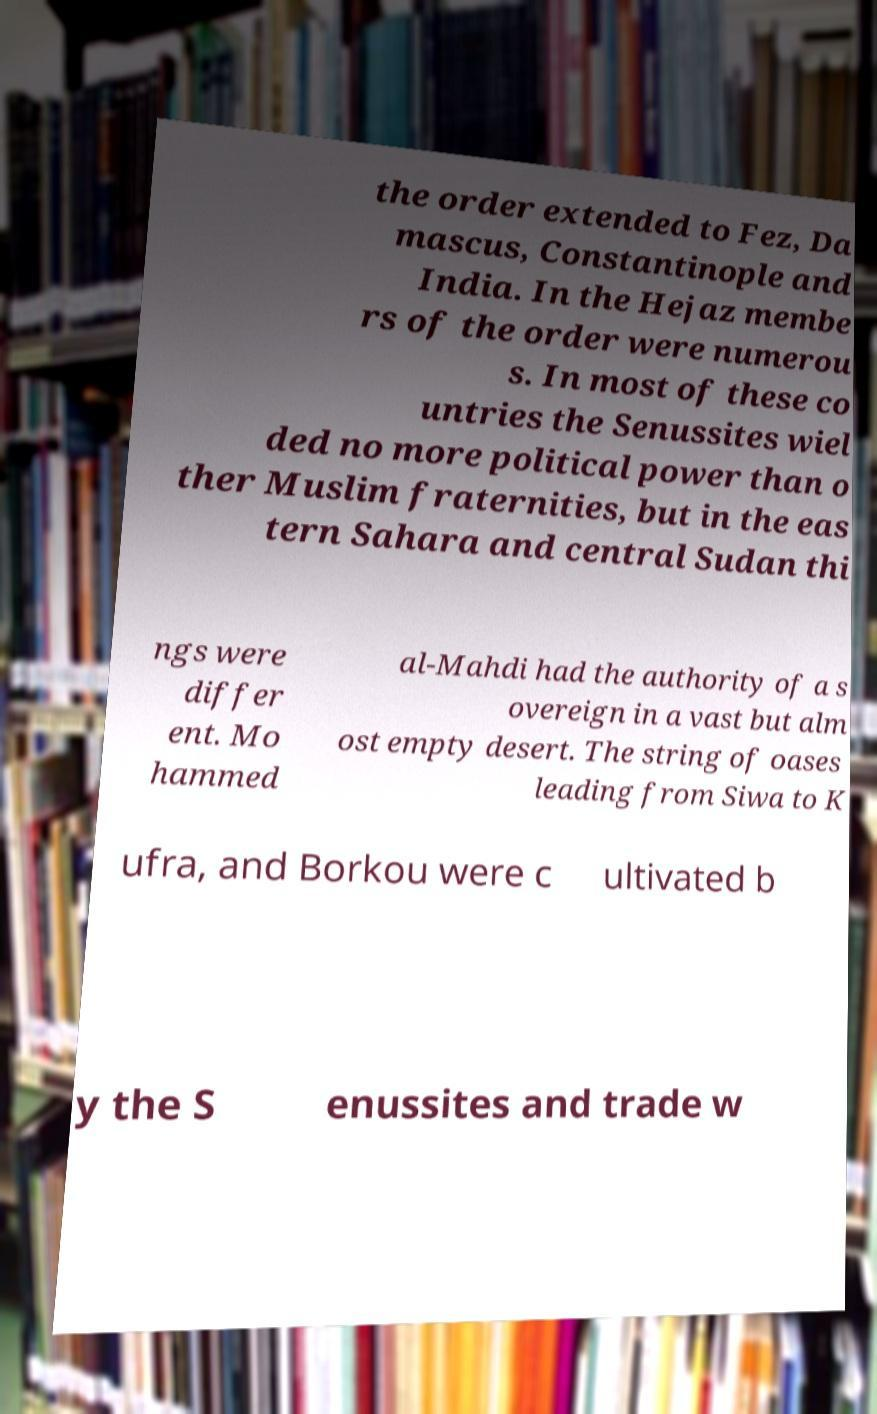Please read and relay the text visible in this image. What does it say? the order extended to Fez, Da mascus, Constantinople and India. In the Hejaz membe rs of the order were numerou s. In most of these co untries the Senussites wiel ded no more political power than o ther Muslim fraternities, but in the eas tern Sahara and central Sudan thi ngs were differ ent. Mo hammed al-Mahdi had the authority of a s overeign in a vast but alm ost empty desert. The string of oases leading from Siwa to K ufra, and Borkou were c ultivated b y the S enussites and trade w 